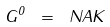<formula> <loc_0><loc_0><loc_500><loc_500>G ^ { 0 } \ = \ N A K</formula> 